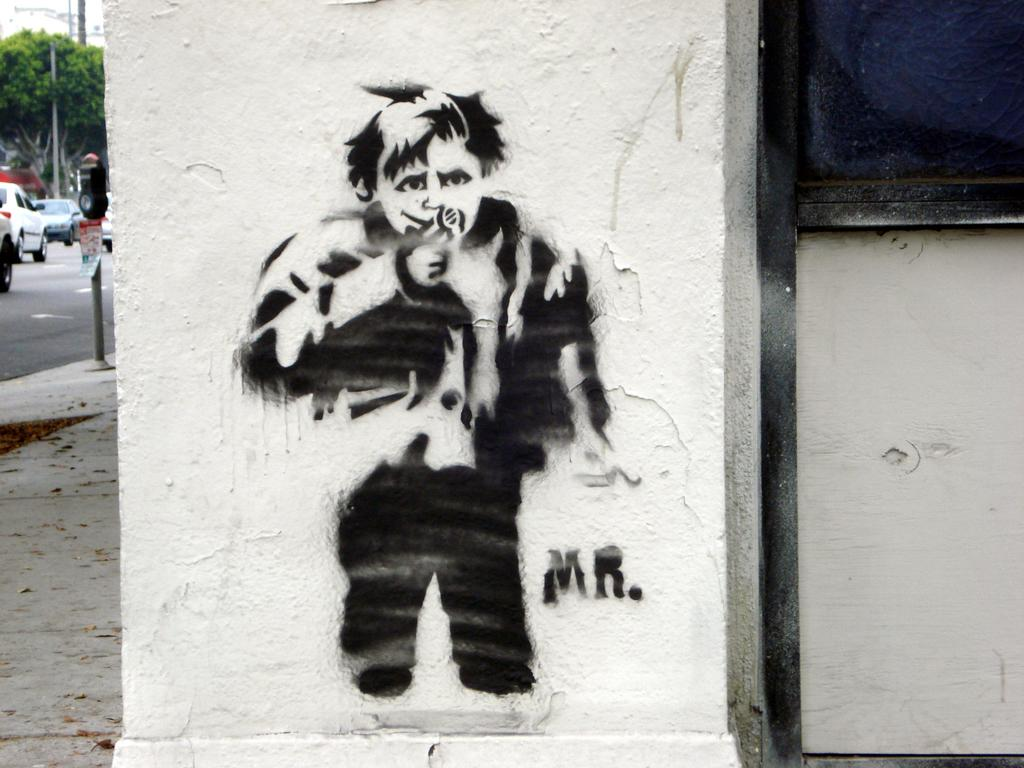What type of structures can be seen in the image? There are buildings in the image. Can you describe any artwork present in the image? There is a painting on a wall in the image. What mode of transportation is visible in the image? Cars are visible moving on the road in the image. What type of plant life is present in the image? There is a tree in the image. What type of education is being offered by the kitty in the image? There is no kitty present in the image, so no education is being offered. 